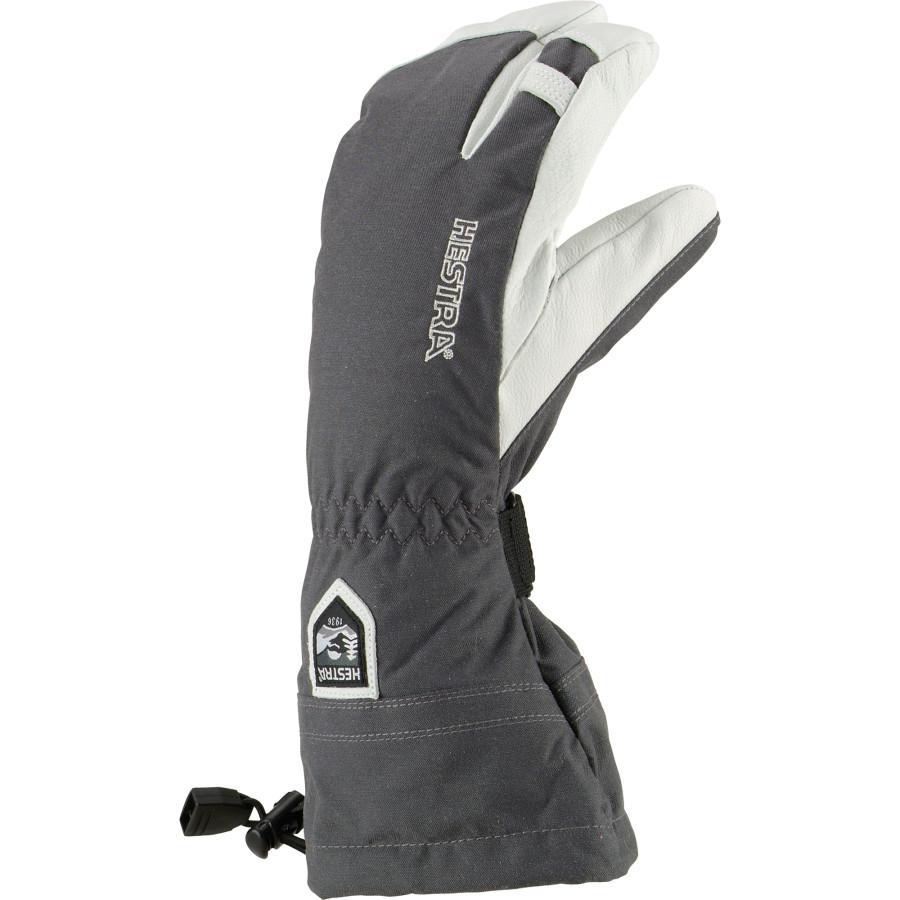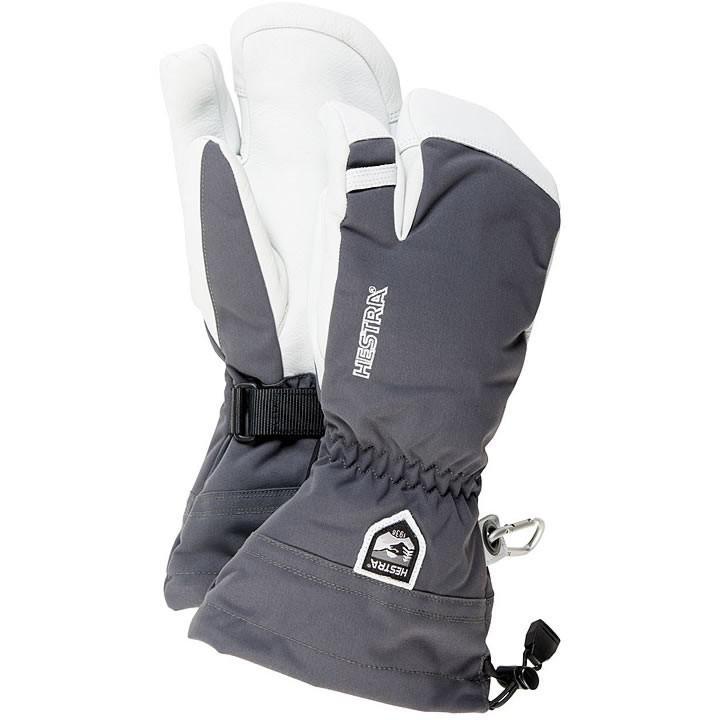The first image is the image on the left, the second image is the image on the right. Considering the images on both sides, is "None of the gloves or mittens make a pair." valid? Answer yes or no. No. The first image is the image on the left, the second image is the image on the right. Analyze the images presented: Is the assertion "One image contains a pair of white and dark two-toned gloves, and the other contains a single glove." valid? Answer yes or no. Yes. 